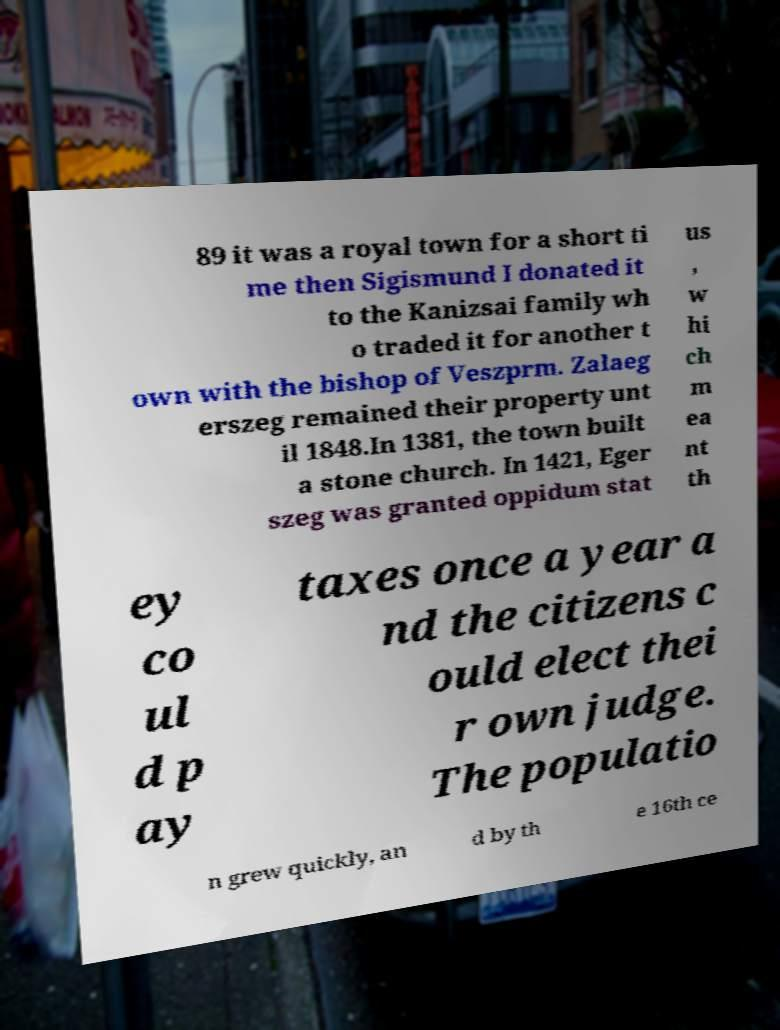Can you accurately transcribe the text from the provided image for me? 89 it was a royal town for a short ti me then Sigismund I donated it to the Kanizsai family wh o traded it for another t own with the bishop of Veszprm. Zalaeg erszeg remained their property unt il 1848.In 1381, the town built a stone church. In 1421, Eger szeg was granted oppidum stat us , w hi ch m ea nt th ey co ul d p ay taxes once a year a nd the citizens c ould elect thei r own judge. The populatio n grew quickly, an d by th e 16th ce 